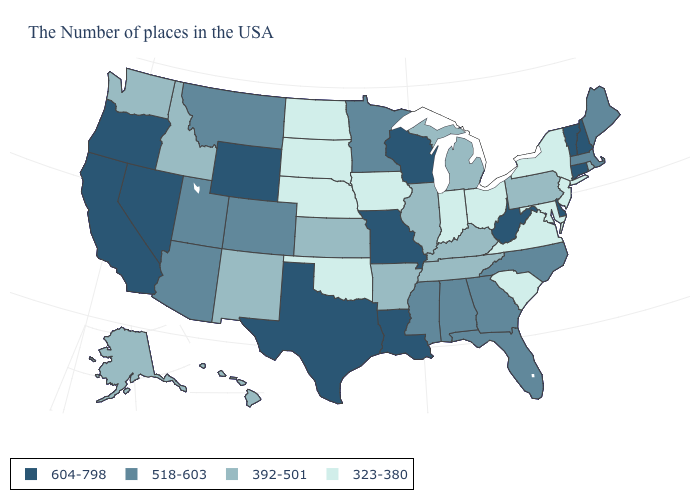Does Wisconsin have the highest value in the MidWest?
Short answer required. Yes. What is the value of North Dakota?
Answer briefly. 323-380. Which states have the highest value in the USA?
Quick response, please. New Hampshire, Vermont, Connecticut, Delaware, West Virginia, Wisconsin, Louisiana, Missouri, Texas, Wyoming, Nevada, California, Oregon. Name the states that have a value in the range 604-798?
Quick response, please. New Hampshire, Vermont, Connecticut, Delaware, West Virginia, Wisconsin, Louisiana, Missouri, Texas, Wyoming, Nevada, California, Oregon. Which states hav the highest value in the South?
Quick response, please. Delaware, West Virginia, Louisiana, Texas. Which states have the lowest value in the USA?
Short answer required. New York, New Jersey, Maryland, Virginia, South Carolina, Ohio, Indiana, Iowa, Nebraska, Oklahoma, South Dakota, North Dakota. Which states have the highest value in the USA?
Answer briefly. New Hampshire, Vermont, Connecticut, Delaware, West Virginia, Wisconsin, Louisiana, Missouri, Texas, Wyoming, Nevada, California, Oregon. Name the states that have a value in the range 518-603?
Quick response, please. Maine, Massachusetts, North Carolina, Florida, Georgia, Alabama, Mississippi, Minnesota, Colorado, Utah, Montana, Arizona. Name the states that have a value in the range 392-501?
Concise answer only. Rhode Island, Pennsylvania, Michigan, Kentucky, Tennessee, Illinois, Arkansas, Kansas, New Mexico, Idaho, Washington, Alaska, Hawaii. What is the lowest value in states that border Maryland?
Give a very brief answer. 323-380. Does the map have missing data?
Concise answer only. No. Is the legend a continuous bar?
Short answer required. No. Name the states that have a value in the range 323-380?
Write a very short answer. New York, New Jersey, Maryland, Virginia, South Carolina, Ohio, Indiana, Iowa, Nebraska, Oklahoma, South Dakota, North Dakota. Name the states that have a value in the range 518-603?
Keep it brief. Maine, Massachusetts, North Carolina, Florida, Georgia, Alabama, Mississippi, Minnesota, Colorado, Utah, Montana, Arizona. Name the states that have a value in the range 392-501?
Concise answer only. Rhode Island, Pennsylvania, Michigan, Kentucky, Tennessee, Illinois, Arkansas, Kansas, New Mexico, Idaho, Washington, Alaska, Hawaii. 